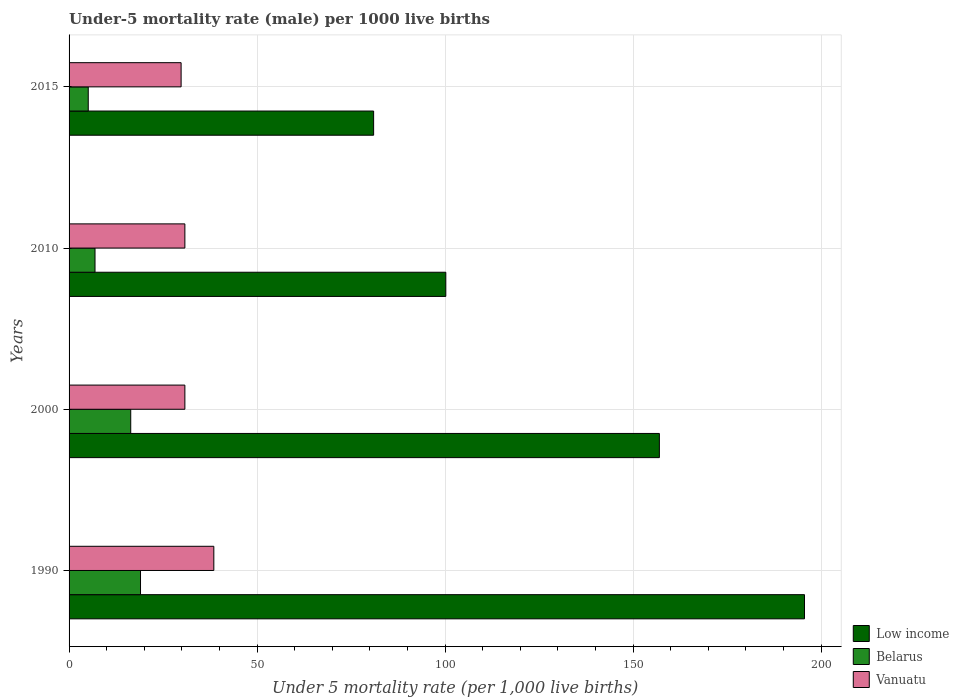What is the label of the 3rd group of bars from the top?
Ensure brevity in your answer.  2000. In how many cases, is the number of bars for a given year not equal to the number of legend labels?
Give a very brief answer. 0. Across all years, what is the maximum under-five mortality rate in Low income?
Keep it short and to the point. 195.6. Across all years, what is the minimum under-five mortality rate in Vanuatu?
Your response must be concise. 29.8. In which year was the under-five mortality rate in Belarus minimum?
Your answer should be compact. 2015. What is the total under-five mortality rate in Vanuatu in the graph?
Your answer should be very brief. 129.9. What is the difference between the under-five mortality rate in Vanuatu in 1990 and that in 2000?
Your answer should be very brief. 7.7. What is the difference between the under-five mortality rate in Belarus in 2010 and the under-five mortality rate in Low income in 2000?
Your answer should be very brief. -150.1. What is the average under-five mortality rate in Low income per year?
Offer a very short reply. 133.45. In the year 2015, what is the difference between the under-five mortality rate in Belarus and under-five mortality rate in Vanuatu?
Offer a terse response. -24.7. In how many years, is the under-five mortality rate in Belarus greater than 70 ?
Your answer should be compact. 0. What is the ratio of the under-five mortality rate in Vanuatu in 1990 to that in 2015?
Provide a short and direct response. 1.29. Is the under-five mortality rate in Vanuatu in 1990 less than that in 2015?
Provide a succinct answer. No. Is the difference between the under-five mortality rate in Belarus in 2010 and 2015 greater than the difference between the under-five mortality rate in Vanuatu in 2010 and 2015?
Your answer should be compact. Yes. What is the difference between the highest and the second highest under-five mortality rate in Vanuatu?
Keep it short and to the point. 7.7. In how many years, is the under-five mortality rate in Low income greater than the average under-five mortality rate in Low income taken over all years?
Ensure brevity in your answer.  2. Is the sum of the under-five mortality rate in Vanuatu in 2010 and 2015 greater than the maximum under-five mortality rate in Low income across all years?
Provide a succinct answer. No. What does the 2nd bar from the bottom in 2015 represents?
Ensure brevity in your answer.  Belarus. Are all the bars in the graph horizontal?
Your answer should be compact. Yes. What is the difference between two consecutive major ticks on the X-axis?
Your response must be concise. 50. Does the graph contain any zero values?
Your response must be concise. No. Does the graph contain grids?
Your answer should be compact. Yes. What is the title of the graph?
Give a very brief answer. Under-5 mortality rate (male) per 1000 live births. What is the label or title of the X-axis?
Your answer should be compact. Under 5 mortality rate (per 1,0 live births). What is the label or title of the Y-axis?
Your answer should be very brief. Years. What is the Under 5 mortality rate (per 1,000 live births) in Low income in 1990?
Give a very brief answer. 195.6. What is the Under 5 mortality rate (per 1,000 live births) of Belarus in 1990?
Provide a succinct answer. 19. What is the Under 5 mortality rate (per 1,000 live births) of Vanuatu in 1990?
Make the answer very short. 38.5. What is the Under 5 mortality rate (per 1,000 live births) in Low income in 2000?
Give a very brief answer. 157. What is the Under 5 mortality rate (per 1,000 live births) of Vanuatu in 2000?
Your answer should be compact. 30.8. What is the Under 5 mortality rate (per 1,000 live births) of Low income in 2010?
Provide a succinct answer. 100.2. What is the Under 5 mortality rate (per 1,000 live births) of Belarus in 2010?
Keep it short and to the point. 6.9. What is the Under 5 mortality rate (per 1,000 live births) of Vanuatu in 2010?
Your answer should be very brief. 30.8. What is the Under 5 mortality rate (per 1,000 live births) in Low income in 2015?
Offer a very short reply. 81. What is the Under 5 mortality rate (per 1,000 live births) of Vanuatu in 2015?
Offer a very short reply. 29.8. Across all years, what is the maximum Under 5 mortality rate (per 1,000 live births) of Low income?
Offer a terse response. 195.6. Across all years, what is the maximum Under 5 mortality rate (per 1,000 live births) of Vanuatu?
Ensure brevity in your answer.  38.5. Across all years, what is the minimum Under 5 mortality rate (per 1,000 live births) of Vanuatu?
Make the answer very short. 29.8. What is the total Under 5 mortality rate (per 1,000 live births) in Low income in the graph?
Your answer should be very brief. 533.8. What is the total Under 5 mortality rate (per 1,000 live births) of Belarus in the graph?
Offer a very short reply. 47.4. What is the total Under 5 mortality rate (per 1,000 live births) of Vanuatu in the graph?
Make the answer very short. 129.9. What is the difference between the Under 5 mortality rate (per 1,000 live births) of Low income in 1990 and that in 2000?
Offer a very short reply. 38.6. What is the difference between the Under 5 mortality rate (per 1,000 live births) of Low income in 1990 and that in 2010?
Make the answer very short. 95.4. What is the difference between the Under 5 mortality rate (per 1,000 live births) of Low income in 1990 and that in 2015?
Offer a terse response. 114.6. What is the difference between the Under 5 mortality rate (per 1,000 live births) in Vanuatu in 1990 and that in 2015?
Offer a terse response. 8.7. What is the difference between the Under 5 mortality rate (per 1,000 live births) of Low income in 2000 and that in 2010?
Give a very brief answer. 56.8. What is the difference between the Under 5 mortality rate (per 1,000 live births) in Vanuatu in 2000 and that in 2010?
Make the answer very short. 0. What is the difference between the Under 5 mortality rate (per 1,000 live births) of Vanuatu in 2000 and that in 2015?
Your answer should be very brief. 1. What is the difference between the Under 5 mortality rate (per 1,000 live births) of Low income in 2010 and that in 2015?
Provide a short and direct response. 19.2. What is the difference between the Under 5 mortality rate (per 1,000 live births) in Belarus in 2010 and that in 2015?
Your answer should be very brief. 1.8. What is the difference between the Under 5 mortality rate (per 1,000 live births) of Vanuatu in 2010 and that in 2015?
Your response must be concise. 1. What is the difference between the Under 5 mortality rate (per 1,000 live births) of Low income in 1990 and the Under 5 mortality rate (per 1,000 live births) of Belarus in 2000?
Keep it short and to the point. 179.2. What is the difference between the Under 5 mortality rate (per 1,000 live births) of Low income in 1990 and the Under 5 mortality rate (per 1,000 live births) of Vanuatu in 2000?
Offer a very short reply. 164.8. What is the difference between the Under 5 mortality rate (per 1,000 live births) in Belarus in 1990 and the Under 5 mortality rate (per 1,000 live births) in Vanuatu in 2000?
Provide a succinct answer. -11.8. What is the difference between the Under 5 mortality rate (per 1,000 live births) in Low income in 1990 and the Under 5 mortality rate (per 1,000 live births) in Belarus in 2010?
Provide a succinct answer. 188.7. What is the difference between the Under 5 mortality rate (per 1,000 live births) of Low income in 1990 and the Under 5 mortality rate (per 1,000 live births) of Vanuatu in 2010?
Ensure brevity in your answer.  164.8. What is the difference between the Under 5 mortality rate (per 1,000 live births) in Belarus in 1990 and the Under 5 mortality rate (per 1,000 live births) in Vanuatu in 2010?
Offer a very short reply. -11.8. What is the difference between the Under 5 mortality rate (per 1,000 live births) in Low income in 1990 and the Under 5 mortality rate (per 1,000 live births) in Belarus in 2015?
Your answer should be compact. 190.5. What is the difference between the Under 5 mortality rate (per 1,000 live births) in Low income in 1990 and the Under 5 mortality rate (per 1,000 live births) in Vanuatu in 2015?
Give a very brief answer. 165.8. What is the difference between the Under 5 mortality rate (per 1,000 live births) of Belarus in 1990 and the Under 5 mortality rate (per 1,000 live births) of Vanuatu in 2015?
Give a very brief answer. -10.8. What is the difference between the Under 5 mortality rate (per 1,000 live births) of Low income in 2000 and the Under 5 mortality rate (per 1,000 live births) of Belarus in 2010?
Your answer should be very brief. 150.1. What is the difference between the Under 5 mortality rate (per 1,000 live births) of Low income in 2000 and the Under 5 mortality rate (per 1,000 live births) of Vanuatu in 2010?
Your response must be concise. 126.2. What is the difference between the Under 5 mortality rate (per 1,000 live births) of Belarus in 2000 and the Under 5 mortality rate (per 1,000 live births) of Vanuatu in 2010?
Provide a succinct answer. -14.4. What is the difference between the Under 5 mortality rate (per 1,000 live births) of Low income in 2000 and the Under 5 mortality rate (per 1,000 live births) of Belarus in 2015?
Keep it short and to the point. 151.9. What is the difference between the Under 5 mortality rate (per 1,000 live births) of Low income in 2000 and the Under 5 mortality rate (per 1,000 live births) of Vanuatu in 2015?
Offer a very short reply. 127.2. What is the difference between the Under 5 mortality rate (per 1,000 live births) in Low income in 2010 and the Under 5 mortality rate (per 1,000 live births) in Belarus in 2015?
Your answer should be very brief. 95.1. What is the difference between the Under 5 mortality rate (per 1,000 live births) of Low income in 2010 and the Under 5 mortality rate (per 1,000 live births) of Vanuatu in 2015?
Keep it short and to the point. 70.4. What is the difference between the Under 5 mortality rate (per 1,000 live births) of Belarus in 2010 and the Under 5 mortality rate (per 1,000 live births) of Vanuatu in 2015?
Keep it short and to the point. -22.9. What is the average Under 5 mortality rate (per 1,000 live births) of Low income per year?
Keep it short and to the point. 133.45. What is the average Under 5 mortality rate (per 1,000 live births) of Belarus per year?
Offer a very short reply. 11.85. What is the average Under 5 mortality rate (per 1,000 live births) in Vanuatu per year?
Your answer should be very brief. 32.48. In the year 1990, what is the difference between the Under 5 mortality rate (per 1,000 live births) of Low income and Under 5 mortality rate (per 1,000 live births) of Belarus?
Ensure brevity in your answer.  176.6. In the year 1990, what is the difference between the Under 5 mortality rate (per 1,000 live births) in Low income and Under 5 mortality rate (per 1,000 live births) in Vanuatu?
Your answer should be compact. 157.1. In the year 1990, what is the difference between the Under 5 mortality rate (per 1,000 live births) in Belarus and Under 5 mortality rate (per 1,000 live births) in Vanuatu?
Offer a terse response. -19.5. In the year 2000, what is the difference between the Under 5 mortality rate (per 1,000 live births) in Low income and Under 5 mortality rate (per 1,000 live births) in Belarus?
Your response must be concise. 140.6. In the year 2000, what is the difference between the Under 5 mortality rate (per 1,000 live births) of Low income and Under 5 mortality rate (per 1,000 live births) of Vanuatu?
Your answer should be compact. 126.2. In the year 2000, what is the difference between the Under 5 mortality rate (per 1,000 live births) of Belarus and Under 5 mortality rate (per 1,000 live births) of Vanuatu?
Offer a terse response. -14.4. In the year 2010, what is the difference between the Under 5 mortality rate (per 1,000 live births) in Low income and Under 5 mortality rate (per 1,000 live births) in Belarus?
Your answer should be compact. 93.3. In the year 2010, what is the difference between the Under 5 mortality rate (per 1,000 live births) in Low income and Under 5 mortality rate (per 1,000 live births) in Vanuatu?
Your answer should be compact. 69.4. In the year 2010, what is the difference between the Under 5 mortality rate (per 1,000 live births) of Belarus and Under 5 mortality rate (per 1,000 live births) of Vanuatu?
Give a very brief answer. -23.9. In the year 2015, what is the difference between the Under 5 mortality rate (per 1,000 live births) in Low income and Under 5 mortality rate (per 1,000 live births) in Belarus?
Your answer should be very brief. 75.9. In the year 2015, what is the difference between the Under 5 mortality rate (per 1,000 live births) of Low income and Under 5 mortality rate (per 1,000 live births) of Vanuatu?
Your answer should be compact. 51.2. In the year 2015, what is the difference between the Under 5 mortality rate (per 1,000 live births) of Belarus and Under 5 mortality rate (per 1,000 live births) of Vanuatu?
Make the answer very short. -24.7. What is the ratio of the Under 5 mortality rate (per 1,000 live births) in Low income in 1990 to that in 2000?
Offer a very short reply. 1.25. What is the ratio of the Under 5 mortality rate (per 1,000 live births) of Belarus in 1990 to that in 2000?
Offer a very short reply. 1.16. What is the ratio of the Under 5 mortality rate (per 1,000 live births) of Low income in 1990 to that in 2010?
Ensure brevity in your answer.  1.95. What is the ratio of the Under 5 mortality rate (per 1,000 live births) in Belarus in 1990 to that in 2010?
Your answer should be very brief. 2.75. What is the ratio of the Under 5 mortality rate (per 1,000 live births) of Low income in 1990 to that in 2015?
Keep it short and to the point. 2.41. What is the ratio of the Under 5 mortality rate (per 1,000 live births) in Belarus in 1990 to that in 2015?
Give a very brief answer. 3.73. What is the ratio of the Under 5 mortality rate (per 1,000 live births) of Vanuatu in 1990 to that in 2015?
Offer a very short reply. 1.29. What is the ratio of the Under 5 mortality rate (per 1,000 live births) in Low income in 2000 to that in 2010?
Offer a very short reply. 1.57. What is the ratio of the Under 5 mortality rate (per 1,000 live births) of Belarus in 2000 to that in 2010?
Keep it short and to the point. 2.38. What is the ratio of the Under 5 mortality rate (per 1,000 live births) of Low income in 2000 to that in 2015?
Your response must be concise. 1.94. What is the ratio of the Under 5 mortality rate (per 1,000 live births) of Belarus in 2000 to that in 2015?
Ensure brevity in your answer.  3.22. What is the ratio of the Under 5 mortality rate (per 1,000 live births) in Vanuatu in 2000 to that in 2015?
Make the answer very short. 1.03. What is the ratio of the Under 5 mortality rate (per 1,000 live births) of Low income in 2010 to that in 2015?
Your answer should be compact. 1.24. What is the ratio of the Under 5 mortality rate (per 1,000 live births) of Belarus in 2010 to that in 2015?
Offer a very short reply. 1.35. What is the ratio of the Under 5 mortality rate (per 1,000 live births) of Vanuatu in 2010 to that in 2015?
Offer a terse response. 1.03. What is the difference between the highest and the second highest Under 5 mortality rate (per 1,000 live births) in Low income?
Offer a very short reply. 38.6. What is the difference between the highest and the lowest Under 5 mortality rate (per 1,000 live births) of Low income?
Provide a succinct answer. 114.6. What is the difference between the highest and the lowest Under 5 mortality rate (per 1,000 live births) of Belarus?
Your answer should be compact. 13.9. What is the difference between the highest and the lowest Under 5 mortality rate (per 1,000 live births) in Vanuatu?
Your answer should be compact. 8.7. 